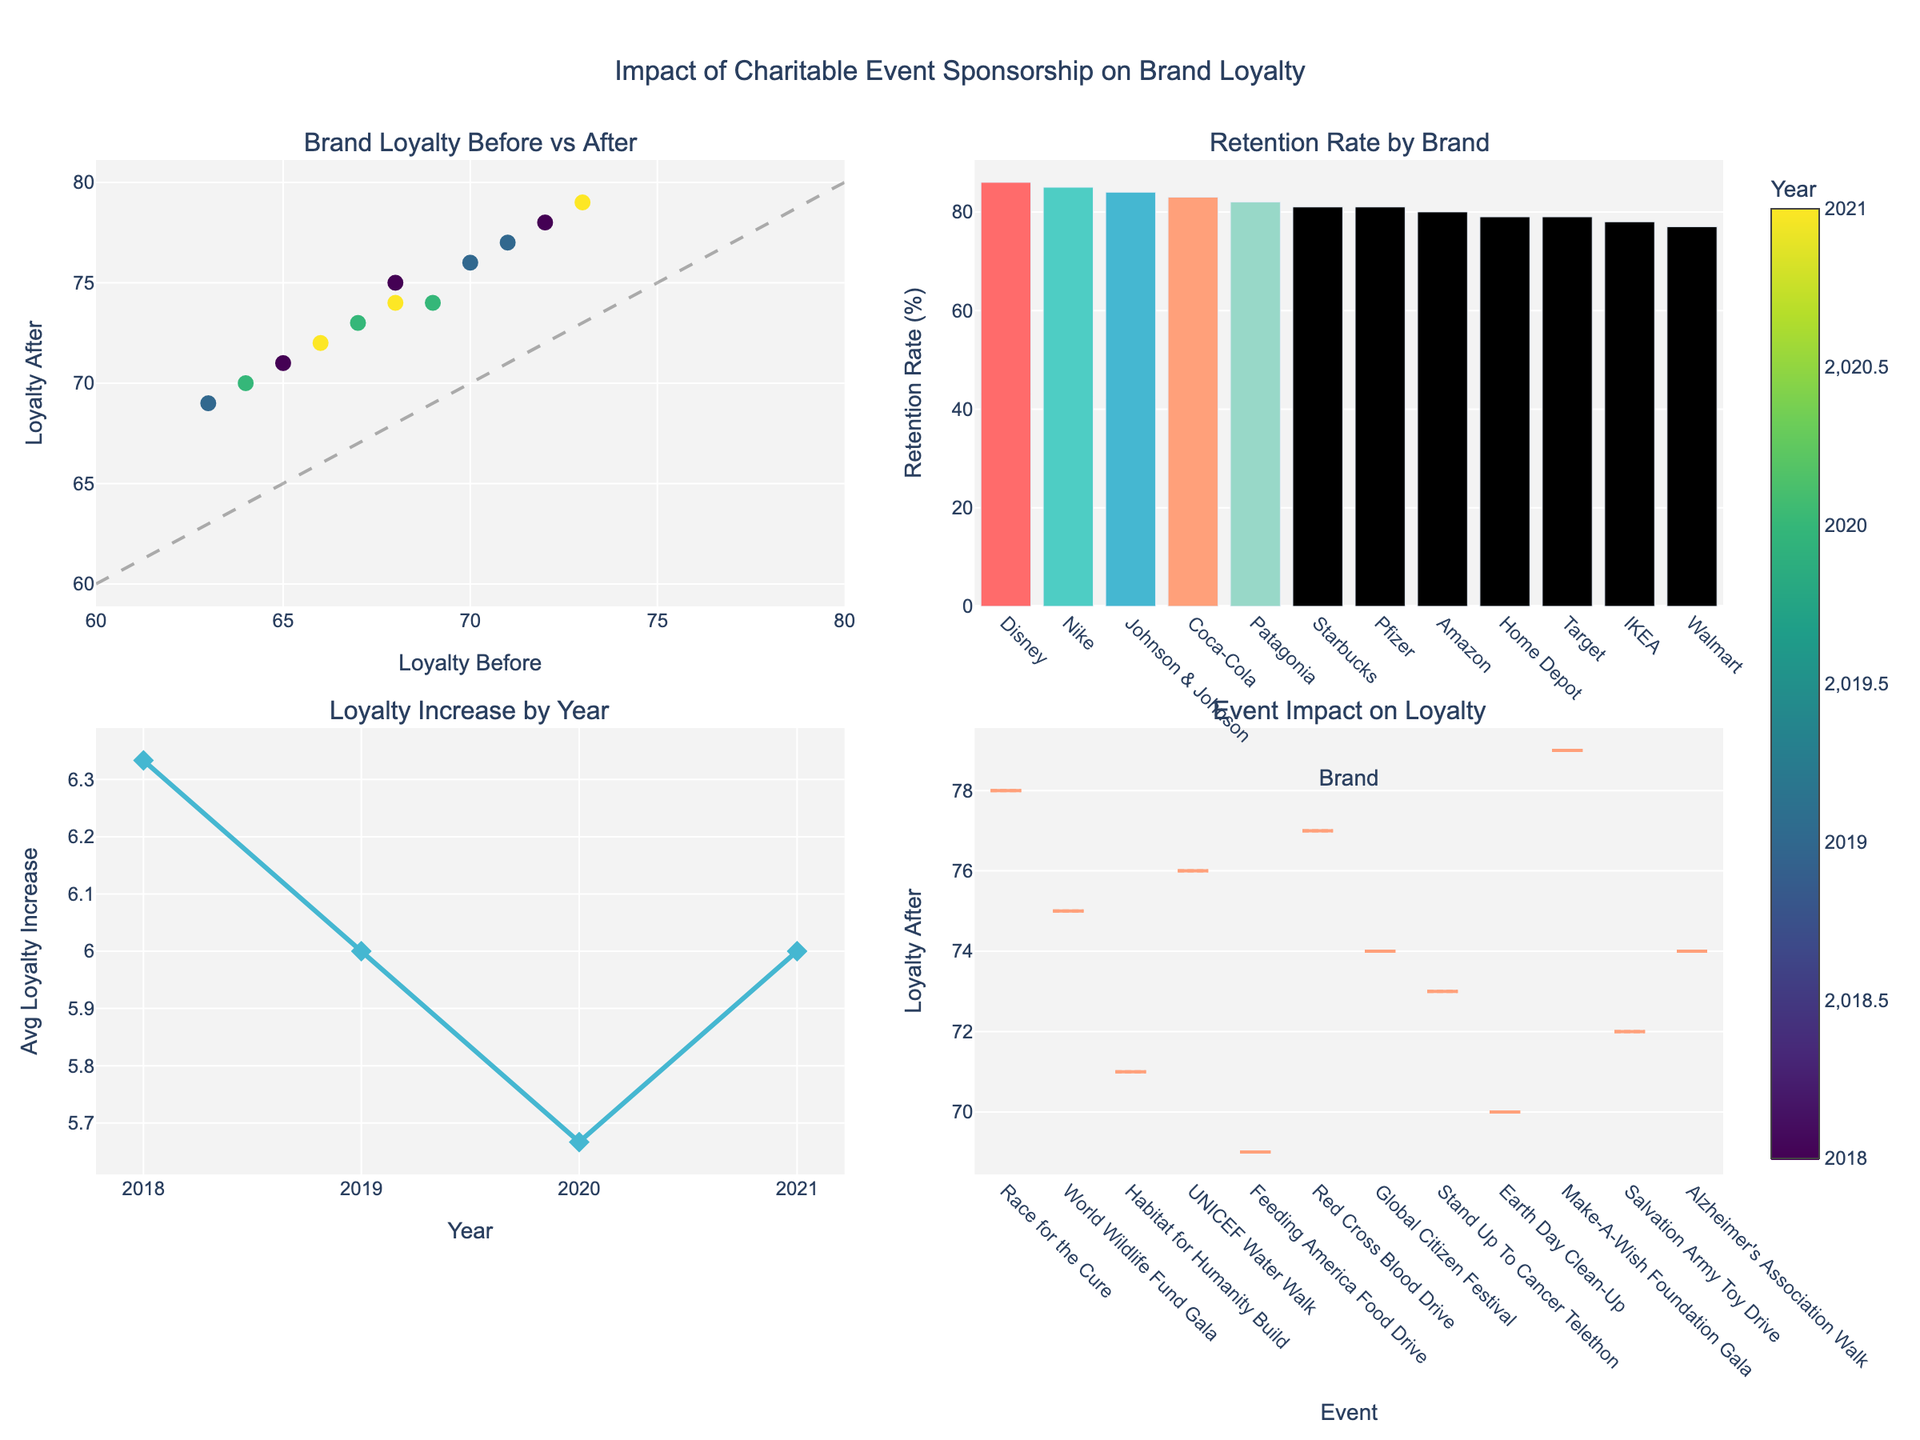How many counties are represented in the "Distance to Legal Aid by County" bar plot? There are separate bars for each county in the "Distance to Legal Aid by County" bar plot. Counting these bars will give the number of counties.
Answer: 15 Which county has the highest attorney-to-population ratio? Look at the bar plot titled "Attorney-to-Population Ratio by County" and identify the county with the tallest bar.
Answer: Salt Lake What is the average distance to legal aid providers across all counties? Sum the distances shown in the "Distance to Legal Aid by County" bar plot and divide it by the number of counties (15).
Answer: 31.8 miles Compare the attorney-to-population ratios between urban and rural areas. Which has the higher average ratio? Calculate the average attorney-to-population ratio for counties labeled as "Urban" and "Rural" in the dataset, then compare the two averages.
Answer: Urban What is the ratio of urban to rural counties represented in the figure? Refer to the pie chart labeled "Urban vs Rural Legal Access" to see the ratio of urban to rural areas.
Answer: 5:10 How does the distance to legal aid providers in rural areas compare to urban areas? Calculate the average distance for rural and urban areas individually and compare the two averages.
Answer: Rural areas have a greater average distance Does there appear to be a correlation between population size and the number of attorneys in a county based on the scatter plot? Look at the scatter plot labeled "Population vs Attorneys". If the data points form an upward trend, there is a positive correlation.
Answer: Yes, a positive correlation Which counties have a distance to legal aid providers greater than 50 miles? Look at the "Distance to Legal Aid by County" bar plot and identify the counties with bars extending beyond the 50 miles mark.
Answer: Uintah, Sevier, Sanpete, Carbon What is the maximum distance to legal aid providers shown in the figure, and which county does it belong to? Identify the tallest bar in the "Distance to Legal Aid by County" plot and note its value and corresponding county.
Answer: 72.4 miles, Uintah How are the data points color-coded in the scatter plot? What does the color represent? The scatter plot data points use a color scale. Look at the color bar next to the plot which shows that color intensity represents the "Distance to Legal Aid".
Answer: Color represents distance to legal aid 